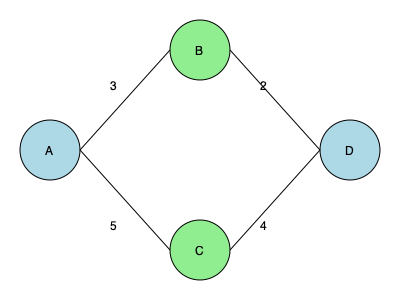In the network diagram above, representing supply distribution routes between camps A, B, C, and D, the numbers on the edges indicate travel time in hours. What is the minimum time required to distribute supplies from camp A to camp D while visiting either camp B or C? To solve this problem, we need to consider two possible paths from A to D:

1. Path A-B-D:
   - Time from A to B: 3 hours
   - Time from B to D: 2 hours
   - Total time: $3 + 2 = 5$ hours

2. Path A-C-D:
   - Time from A to C: 5 hours
   - Time from C to D: 4 hours
   - Total time: $5 + 4 = 9$ hours

The minimum time required is the shorter of these two paths. In this case, the path A-B-D takes 5 hours, which is less than the 9 hours required for path A-C-D.

Therefore, the minimum time required to distribute supplies from camp A to camp D while visiting either camp B or C is 5 hours.
Answer: 5 hours 